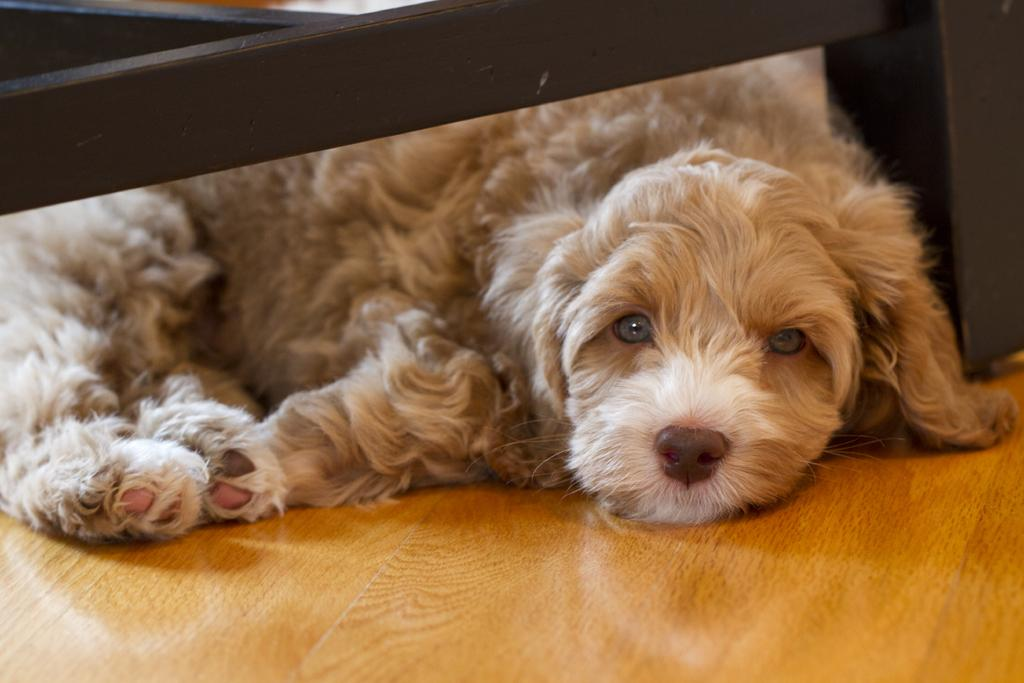What type of animal is in the image? There is a dog in the image. What color is the dog? The dog is cream-colored. What is the dog standing on in the image? The dog is on a brown surface. Can you describe another object in the image besides the dog? There is a black object visible in the image. What degree does the fish have in the image? There is no fish present in the image, so it cannot have a degree. 